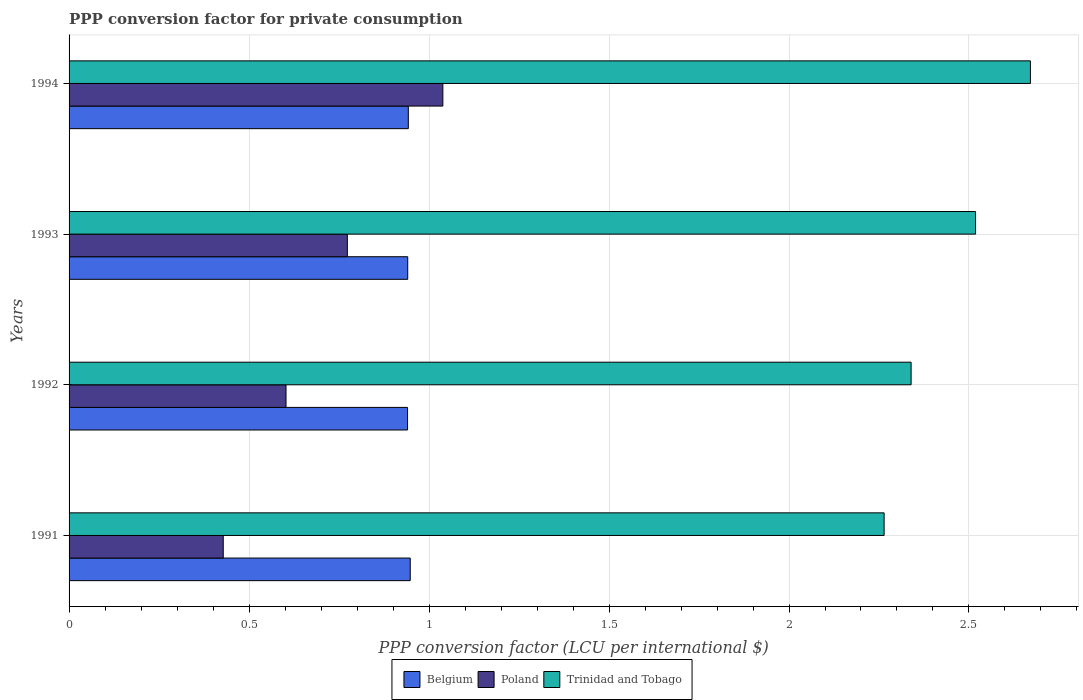How many different coloured bars are there?
Offer a very short reply. 3. How many groups of bars are there?
Provide a succinct answer. 4. Are the number of bars per tick equal to the number of legend labels?
Your response must be concise. Yes. How many bars are there on the 4th tick from the top?
Offer a terse response. 3. How many bars are there on the 3rd tick from the bottom?
Make the answer very short. 3. What is the label of the 3rd group of bars from the top?
Offer a terse response. 1992. In how many cases, is the number of bars for a given year not equal to the number of legend labels?
Ensure brevity in your answer.  0. What is the PPP conversion factor for private consumption in Belgium in 1994?
Ensure brevity in your answer.  0.94. Across all years, what is the maximum PPP conversion factor for private consumption in Poland?
Ensure brevity in your answer.  1.04. Across all years, what is the minimum PPP conversion factor for private consumption in Trinidad and Tobago?
Give a very brief answer. 2.26. In which year was the PPP conversion factor for private consumption in Poland maximum?
Offer a very short reply. 1994. In which year was the PPP conversion factor for private consumption in Belgium minimum?
Offer a terse response. 1992. What is the total PPP conversion factor for private consumption in Trinidad and Tobago in the graph?
Your answer should be compact. 9.79. What is the difference between the PPP conversion factor for private consumption in Trinidad and Tobago in 1992 and that in 1993?
Offer a very short reply. -0.18. What is the difference between the PPP conversion factor for private consumption in Poland in 1993 and the PPP conversion factor for private consumption in Belgium in 1992?
Give a very brief answer. -0.17. What is the average PPP conversion factor for private consumption in Trinidad and Tobago per year?
Your answer should be compact. 2.45. In the year 1992, what is the difference between the PPP conversion factor for private consumption in Trinidad and Tobago and PPP conversion factor for private consumption in Belgium?
Keep it short and to the point. 1.4. What is the ratio of the PPP conversion factor for private consumption in Trinidad and Tobago in 1993 to that in 1994?
Give a very brief answer. 0.94. Is the difference between the PPP conversion factor for private consumption in Trinidad and Tobago in 1991 and 1994 greater than the difference between the PPP conversion factor for private consumption in Belgium in 1991 and 1994?
Offer a terse response. No. What is the difference between the highest and the second highest PPP conversion factor for private consumption in Belgium?
Give a very brief answer. 0.01. What is the difference between the highest and the lowest PPP conversion factor for private consumption in Belgium?
Your answer should be compact. 0.01. What does the 1st bar from the top in 1991 represents?
Offer a terse response. Trinidad and Tobago. What does the 3rd bar from the bottom in 1992 represents?
Provide a short and direct response. Trinidad and Tobago. How many years are there in the graph?
Ensure brevity in your answer.  4. Are the values on the major ticks of X-axis written in scientific E-notation?
Keep it short and to the point. No. Does the graph contain grids?
Give a very brief answer. Yes. Where does the legend appear in the graph?
Make the answer very short. Bottom center. How are the legend labels stacked?
Your answer should be compact. Horizontal. What is the title of the graph?
Provide a short and direct response. PPP conversion factor for private consumption. What is the label or title of the X-axis?
Provide a succinct answer. PPP conversion factor (LCU per international $). What is the label or title of the Y-axis?
Offer a terse response. Years. What is the PPP conversion factor (LCU per international $) in Belgium in 1991?
Ensure brevity in your answer.  0.95. What is the PPP conversion factor (LCU per international $) of Poland in 1991?
Your response must be concise. 0.43. What is the PPP conversion factor (LCU per international $) in Trinidad and Tobago in 1991?
Ensure brevity in your answer.  2.26. What is the PPP conversion factor (LCU per international $) in Belgium in 1992?
Your answer should be compact. 0.94. What is the PPP conversion factor (LCU per international $) of Poland in 1992?
Your answer should be compact. 0.6. What is the PPP conversion factor (LCU per international $) of Trinidad and Tobago in 1992?
Make the answer very short. 2.34. What is the PPP conversion factor (LCU per international $) in Belgium in 1993?
Offer a terse response. 0.94. What is the PPP conversion factor (LCU per international $) of Poland in 1993?
Offer a terse response. 0.77. What is the PPP conversion factor (LCU per international $) of Trinidad and Tobago in 1993?
Give a very brief answer. 2.52. What is the PPP conversion factor (LCU per international $) of Belgium in 1994?
Offer a very short reply. 0.94. What is the PPP conversion factor (LCU per international $) in Poland in 1994?
Ensure brevity in your answer.  1.04. What is the PPP conversion factor (LCU per international $) of Trinidad and Tobago in 1994?
Give a very brief answer. 2.67. Across all years, what is the maximum PPP conversion factor (LCU per international $) of Belgium?
Give a very brief answer. 0.95. Across all years, what is the maximum PPP conversion factor (LCU per international $) of Poland?
Your answer should be very brief. 1.04. Across all years, what is the maximum PPP conversion factor (LCU per international $) of Trinidad and Tobago?
Your answer should be very brief. 2.67. Across all years, what is the minimum PPP conversion factor (LCU per international $) in Belgium?
Offer a very short reply. 0.94. Across all years, what is the minimum PPP conversion factor (LCU per international $) of Poland?
Offer a very short reply. 0.43. Across all years, what is the minimum PPP conversion factor (LCU per international $) of Trinidad and Tobago?
Give a very brief answer. 2.26. What is the total PPP conversion factor (LCU per international $) in Belgium in the graph?
Your response must be concise. 3.77. What is the total PPP conversion factor (LCU per international $) in Poland in the graph?
Make the answer very short. 2.84. What is the total PPP conversion factor (LCU per international $) in Trinidad and Tobago in the graph?
Provide a succinct answer. 9.79. What is the difference between the PPP conversion factor (LCU per international $) of Belgium in 1991 and that in 1992?
Make the answer very short. 0.01. What is the difference between the PPP conversion factor (LCU per international $) in Poland in 1991 and that in 1992?
Provide a short and direct response. -0.17. What is the difference between the PPP conversion factor (LCU per international $) in Trinidad and Tobago in 1991 and that in 1992?
Make the answer very short. -0.07. What is the difference between the PPP conversion factor (LCU per international $) of Belgium in 1991 and that in 1993?
Your answer should be very brief. 0.01. What is the difference between the PPP conversion factor (LCU per international $) in Poland in 1991 and that in 1993?
Give a very brief answer. -0.34. What is the difference between the PPP conversion factor (LCU per international $) of Trinidad and Tobago in 1991 and that in 1993?
Give a very brief answer. -0.25. What is the difference between the PPP conversion factor (LCU per international $) of Belgium in 1991 and that in 1994?
Offer a terse response. 0.01. What is the difference between the PPP conversion factor (LCU per international $) of Poland in 1991 and that in 1994?
Your answer should be very brief. -0.61. What is the difference between the PPP conversion factor (LCU per international $) in Trinidad and Tobago in 1991 and that in 1994?
Make the answer very short. -0.41. What is the difference between the PPP conversion factor (LCU per international $) of Belgium in 1992 and that in 1993?
Keep it short and to the point. -0. What is the difference between the PPP conversion factor (LCU per international $) in Poland in 1992 and that in 1993?
Ensure brevity in your answer.  -0.17. What is the difference between the PPP conversion factor (LCU per international $) in Trinidad and Tobago in 1992 and that in 1993?
Provide a short and direct response. -0.18. What is the difference between the PPP conversion factor (LCU per international $) in Belgium in 1992 and that in 1994?
Your answer should be compact. -0. What is the difference between the PPP conversion factor (LCU per international $) in Poland in 1992 and that in 1994?
Ensure brevity in your answer.  -0.44. What is the difference between the PPP conversion factor (LCU per international $) of Trinidad and Tobago in 1992 and that in 1994?
Offer a very short reply. -0.33. What is the difference between the PPP conversion factor (LCU per international $) in Belgium in 1993 and that in 1994?
Provide a short and direct response. -0. What is the difference between the PPP conversion factor (LCU per international $) of Poland in 1993 and that in 1994?
Provide a succinct answer. -0.27. What is the difference between the PPP conversion factor (LCU per international $) of Trinidad and Tobago in 1993 and that in 1994?
Give a very brief answer. -0.15. What is the difference between the PPP conversion factor (LCU per international $) of Belgium in 1991 and the PPP conversion factor (LCU per international $) of Poland in 1992?
Make the answer very short. 0.35. What is the difference between the PPP conversion factor (LCU per international $) in Belgium in 1991 and the PPP conversion factor (LCU per international $) in Trinidad and Tobago in 1992?
Provide a short and direct response. -1.39. What is the difference between the PPP conversion factor (LCU per international $) in Poland in 1991 and the PPP conversion factor (LCU per international $) in Trinidad and Tobago in 1992?
Make the answer very short. -1.91. What is the difference between the PPP conversion factor (LCU per international $) in Belgium in 1991 and the PPP conversion factor (LCU per international $) in Poland in 1993?
Your answer should be very brief. 0.17. What is the difference between the PPP conversion factor (LCU per international $) of Belgium in 1991 and the PPP conversion factor (LCU per international $) of Trinidad and Tobago in 1993?
Keep it short and to the point. -1.57. What is the difference between the PPP conversion factor (LCU per international $) in Poland in 1991 and the PPP conversion factor (LCU per international $) in Trinidad and Tobago in 1993?
Offer a terse response. -2.09. What is the difference between the PPP conversion factor (LCU per international $) in Belgium in 1991 and the PPP conversion factor (LCU per international $) in Poland in 1994?
Keep it short and to the point. -0.09. What is the difference between the PPP conversion factor (LCU per international $) in Belgium in 1991 and the PPP conversion factor (LCU per international $) in Trinidad and Tobago in 1994?
Keep it short and to the point. -1.72. What is the difference between the PPP conversion factor (LCU per international $) of Poland in 1991 and the PPP conversion factor (LCU per international $) of Trinidad and Tobago in 1994?
Your answer should be compact. -2.24. What is the difference between the PPP conversion factor (LCU per international $) in Belgium in 1992 and the PPP conversion factor (LCU per international $) in Poland in 1993?
Offer a terse response. 0.17. What is the difference between the PPP conversion factor (LCU per international $) in Belgium in 1992 and the PPP conversion factor (LCU per international $) in Trinidad and Tobago in 1993?
Give a very brief answer. -1.58. What is the difference between the PPP conversion factor (LCU per international $) in Poland in 1992 and the PPP conversion factor (LCU per international $) in Trinidad and Tobago in 1993?
Ensure brevity in your answer.  -1.92. What is the difference between the PPP conversion factor (LCU per international $) in Belgium in 1992 and the PPP conversion factor (LCU per international $) in Poland in 1994?
Keep it short and to the point. -0.1. What is the difference between the PPP conversion factor (LCU per international $) of Belgium in 1992 and the PPP conversion factor (LCU per international $) of Trinidad and Tobago in 1994?
Your answer should be very brief. -1.73. What is the difference between the PPP conversion factor (LCU per international $) of Poland in 1992 and the PPP conversion factor (LCU per international $) of Trinidad and Tobago in 1994?
Provide a succinct answer. -2.07. What is the difference between the PPP conversion factor (LCU per international $) of Belgium in 1993 and the PPP conversion factor (LCU per international $) of Poland in 1994?
Keep it short and to the point. -0.1. What is the difference between the PPP conversion factor (LCU per international $) of Belgium in 1993 and the PPP conversion factor (LCU per international $) of Trinidad and Tobago in 1994?
Provide a succinct answer. -1.73. What is the difference between the PPP conversion factor (LCU per international $) in Poland in 1993 and the PPP conversion factor (LCU per international $) in Trinidad and Tobago in 1994?
Make the answer very short. -1.9. What is the average PPP conversion factor (LCU per international $) in Belgium per year?
Provide a succinct answer. 0.94. What is the average PPP conversion factor (LCU per international $) of Poland per year?
Provide a short and direct response. 0.71. What is the average PPP conversion factor (LCU per international $) of Trinidad and Tobago per year?
Give a very brief answer. 2.45. In the year 1991, what is the difference between the PPP conversion factor (LCU per international $) of Belgium and PPP conversion factor (LCU per international $) of Poland?
Offer a very short reply. 0.52. In the year 1991, what is the difference between the PPP conversion factor (LCU per international $) of Belgium and PPP conversion factor (LCU per international $) of Trinidad and Tobago?
Your response must be concise. -1.32. In the year 1991, what is the difference between the PPP conversion factor (LCU per international $) of Poland and PPP conversion factor (LCU per international $) of Trinidad and Tobago?
Offer a very short reply. -1.84. In the year 1992, what is the difference between the PPP conversion factor (LCU per international $) in Belgium and PPP conversion factor (LCU per international $) in Poland?
Keep it short and to the point. 0.34. In the year 1992, what is the difference between the PPP conversion factor (LCU per international $) in Belgium and PPP conversion factor (LCU per international $) in Trinidad and Tobago?
Your answer should be compact. -1.4. In the year 1992, what is the difference between the PPP conversion factor (LCU per international $) in Poland and PPP conversion factor (LCU per international $) in Trinidad and Tobago?
Ensure brevity in your answer.  -1.74. In the year 1993, what is the difference between the PPP conversion factor (LCU per international $) in Belgium and PPP conversion factor (LCU per international $) in Poland?
Your answer should be very brief. 0.17. In the year 1993, what is the difference between the PPP conversion factor (LCU per international $) of Belgium and PPP conversion factor (LCU per international $) of Trinidad and Tobago?
Make the answer very short. -1.58. In the year 1993, what is the difference between the PPP conversion factor (LCU per international $) of Poland and PPP conversion factor (LCU per international $) of Trinidad and Tobago?
Provide a succinct answer. -1.75. In the year 1994, what is the difference between the PPP conversion factor (LCU per international $) in Belgium and PPP conversion factor (LCU per international $) in Poland?
Your answer should be compact. -0.1. In the year 1994, what is the difference between the PPP conversion factor (LCU per international $) in Belgium and PPP conversion factor (LCU per international $) in Trinidad and Tobago?
Your response must be concise. -1.73. In the year 1994, what is the difference between the PPP conversion factor (LCU per international $) in Poland and PPP conversion factor (LCU per international $) in Trinidad and Tobago?
Your answer should be compact. -1.63. What is the ratio of the PPP conversion factor (LCU per international $) of Belgium in 1991 to that in 1992?
Make the answer very short. 1.01. What is the ratio of the PPP conversion factor (LCU per international $) in Poland in 1991 to that in 1992?
Ensure brevity in your answer.  0.71. What is the ratio of the PPP conversion factor (LCU per international $) in Belgium in 1991 to that in 1993?
Make the answer very short. 1.01. What is the ratio of the PPP conversion factor (LCU per international $) of Poland in 1991 to that in 1993?
Make the answer very short. 0.55. What is the ratio of the PPP conversion factor (LCU per international $) in Trinidad and Tobago in 1991 to that in 1993?
Provide a short and direct response. 0.9. What is the ratio of the PPP conversion factor (LCU per international $) of Poland in 1991 to that in 1994?
Your answer should be compact. 0.41. What is the ratio of the PPP conversion factor (LCU per international $) of Trinidad and Tobago in 1991 to that in 1994?
Keep it short and to the point. 0.85. What is the ratio of the PPP conversion factor (LCU per international $) in Poland in 1992 to that in 1993?
Offer a terse response. 0.78. What is the ratio of the PPP conversion factor (LCU per international $) of Trinidad and Tobago in 1992 to that in 1993?
Your response must be concise. 0.93. What is the ratio of the PPP conversion factor (LCU per international $) of Belgium in 1992 to that in 1994?
Make the answer very short. 1. What is the ratio of the PPP conversion factor (LCU per international $) of Poland in 1992 to that in 1994?
Offer a terse response. 0.58. What is the ratio of the PPP conversion factor (LCU per international $) of Trinidad and Tobago in 1992 to that in 1994?
Ensure brevity in your answer.  0.88. What is the ratio of the PPP conversion factor (LCU per international $) in Belgium in 1993 to that in 1994?
Keep it short and to the point. 1. What is the ratio of the PPP conversion factor (LCU per international $) of Poland in 1993 to that in 1994?
Give a very brief answer. 0.74. What is the ratio of the PPP conversion factor (LCU per international $) in Trinidad and Tobago in 1993 to that in 1994?
Offer a very short reply. 0.94. What is the difference between the highest and the second highest PPP conversion factor (LCU per international $) in Belgium?
Your response must be concise. 0.01. What is the difference between the highest and the second highest PPP conversion factor (LCU per international $) in Poland?
Make the answer very short. 0.27. What is the difference between the highest and the second highest PPP conversion factor (LCU per international $) of Trinidad and Tobago?
Offer a very short reply. 0.15. What is the difference between the highest and the lowest PPP conversion factor (LCU per international $) of Belgium?
Your response must be concise. 0.01. What is the difference between the highest and the lowest PPP conversion factor (LCU per international $) of Poland?
Provide a succinct answer. 0.61. What is the difference between the highest and the lowest PPP conversion factor (LCU per international $) in Trinidad and Tobago?
Provide a succinct answer. 0.41. 